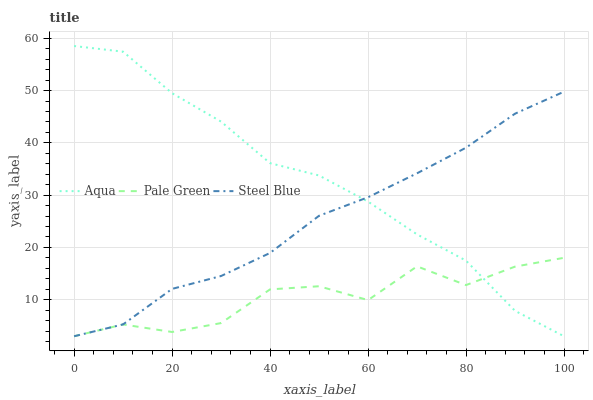Does Pale Green have the minimum area under the curve?
Answer yes or no. Yes. Does Aqua have the maximum area under the curve?
Answer yes or no. Yes. Does Steel Blue have the minimum area under the curve?
Answer yes or no. No. Does Steel Blue have the maximum area under the curve?
Answer yes or no. No. Is Steel Blue the smoothest?
Answer yes or no. Yes. Is Pale Green the roughest?
Answer yes or no. Yes. Is Aqua the smoothest?
Answer yes or no. No. Is Aqua the roughest?
Answer yes or no. No. Does Aqua have the highest value?
Answer yes or no. Yes. Does Steel Blue have the highest value?
Answer yes or no. No. Does Aqua intersect Steel Blue?
Answer yes or no. Yes. Is Aqua less than Steel Blue?
Answer yes or no. No. Is Aqua greater than Steel Blue?
Answer yes or no. No. 